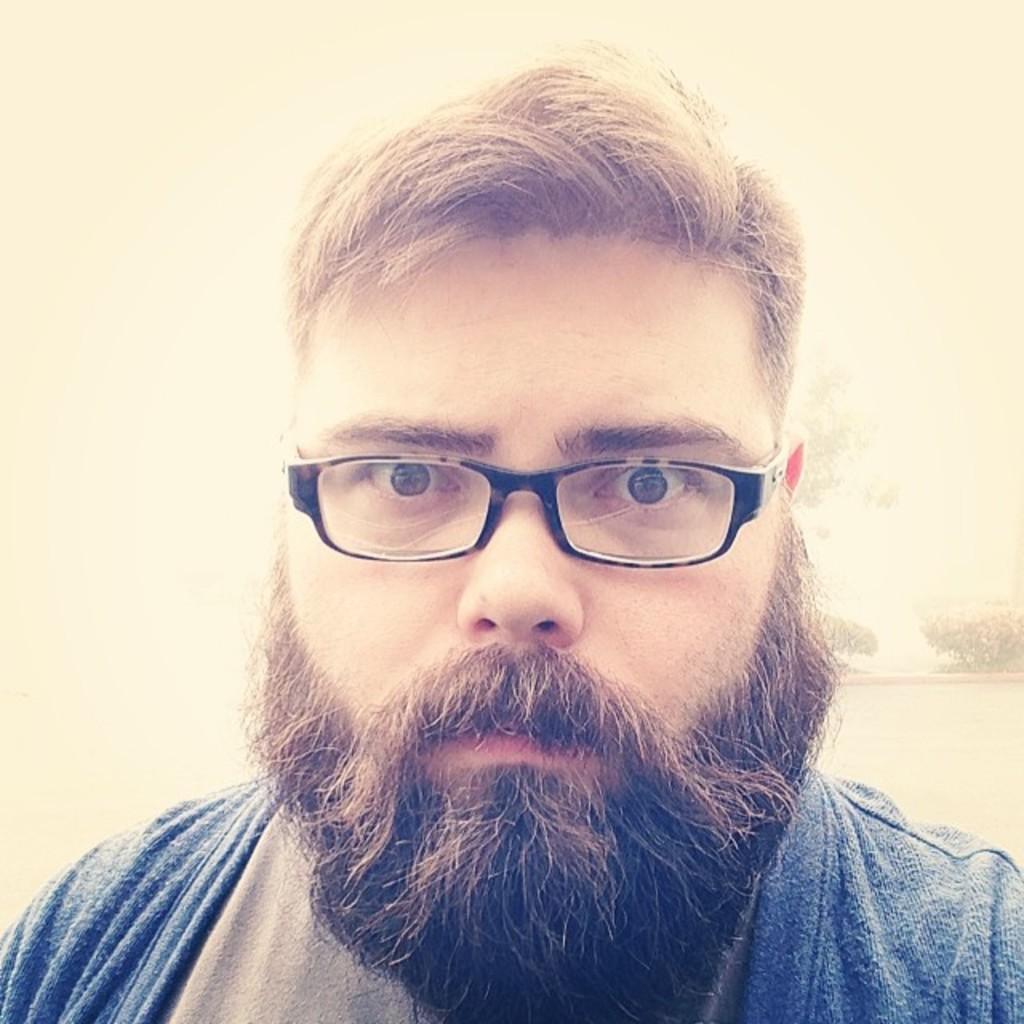Can you describe this image briefly? In this image we can see a person wearing spectacles. 